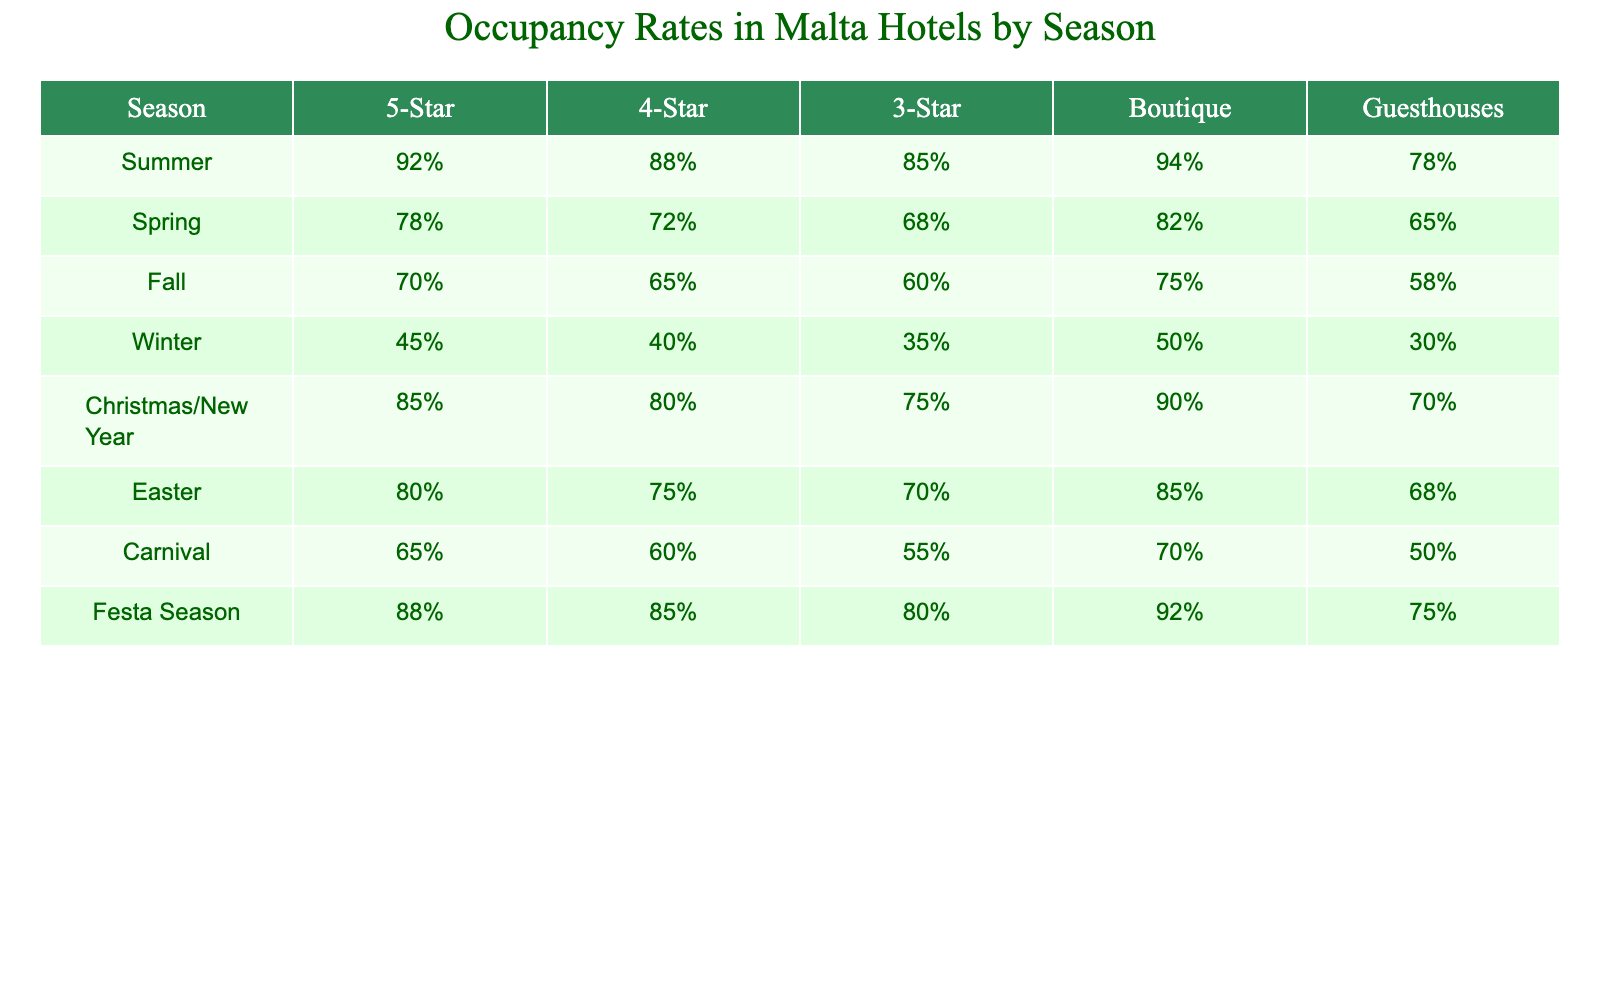What season has the highest occupancy rate for 5-Star hotels? The table shows that in the Summer season, the occupancy rate for 5-Star hotels is 92%, which is higher than all other seasons listed.
Answer: Summer Which hotel category has the lowest occupancy rate during Winter? According to the table, Guesthouses have the lowest occupancy rate during Winter at 30%.
Answer: Guesthouses What is the occupancy rate difference between 4-Star hotels in Summer and Winter? The occupancy rate for 4-Star hotels in Summer is 88% and in Winter it is 40%. The difference is 88% - 40% = 48%.
Answer: 48% In which season do Boutique hotels have the highest occupancy rate? The table indicates that the highest occupancy rate for Boutique hotels is in Christmas/New Year at 90%.
Answer: Christmas/New Year What is the average occupancy rate for 3-Star hotels across all seasons? Summing the occupancy rates for 3-Star hotels from each season gives: (85% + 68% + 60% + 35% + 75% + 70% + 55% + 80%) =  78%, and dividing by the number of seasons (8) yields an average of 78%.
Answer: 78% During which season do Guesthouses have their highest occupancy rate? The table shows that Guesthouses have their highest occupancy rate during Easter at 68%.
Answer: Easter Is the occupancy rate for 4-Star hotels during the Festa Season higher or lower than that during Spring? The occupancy rate for 4-Star hotels during the Festa Season is 85%, while during Spring it is 72%. Since 85% > 72%, it is higher.
Answer: Higher What is the range of occupancy rates for 5-Star hotels across all seasons? The highest occupancy rate for 5-Star hotels is 92% in Summer and the lowest is 45% in Winter, so the range is 92% - 45% = 47%.
Answer: 47% Do 3-Star hotels ever exceed 70% occupancy in the Fall? The table shows that the occupancy rate for 3-Star hotels in Fall is 60%, which does not exceed 70%.
Answer: No What is the total occupancy rate for all hotel categories during the Christmas/New Year season? Adding up the occupancy rates for all categories during Christmas/New Year yields: 85% + 80% + 75% + 90% + 70% = 400%.
Answer: 400% 